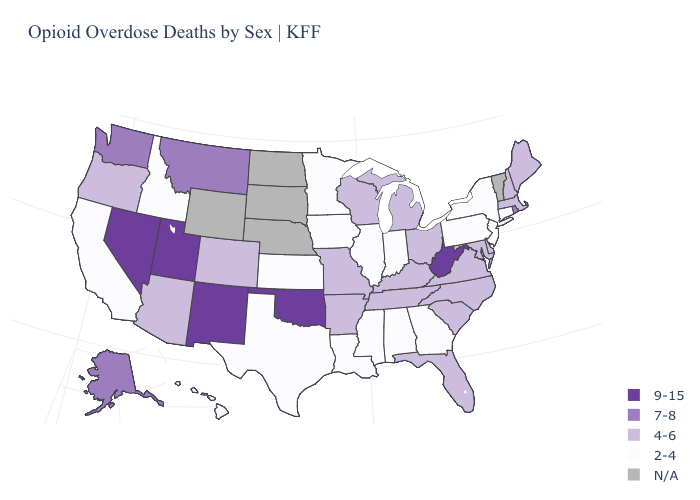Name the states that have a value in the range 4-6?
Quick response, please. Arizona, Arkansas, Colorado, Delaware, Florida, Kentucky, Maine, Maryland, Massachusetts, Michigan, Missouri, New Hampshire, North Carolina, Ohio, Oregon, South Carolina, Tennessee, Virginia, Wisconsin. Does the map have missing data?
Write a very short answer. Yes. Does the map have missing data?
Write a very short answer. Yes. What is the lowest value in the South?
Write a very short answer. 2-4. What is the highest value in the USA?
Be succinct. 9-15. What is the lowest value in the MidWest?
Quick response, please. 2-4. Which states have the lowest value in the MidWest?
Give a very brief answer. Illinois, Indiana, Iowa, Kansas, Minnesota. Name the states that have a value in the range 2-4?
Quick response, please. Alabama, California, Connecticut, Georgia, Hawaii, Idaho, Illinois, Indiana, Iowa, Kansas, Louisiana, Minnesota, Mississippi, New Jersey, New York, Pennsylvania, Texas. What is the highest value in the Northeast ?
Short answer required. 7-8. What is the value of South Carolina?
Quick response, please. 4-6. Is the legend a continuous bar?
Be succinct. No. What is the value of Illinois?
Be succinct. 2-4. Which states have the highest value in the USA?
Write a very short answer. Nevada, New Mexico, Oklahoma, Utah, West Virginia. Name the states that have a value in the range 9-15?
Be succinct. Nevada, New Mexico, Oklahoma, Utah, West Virginia. Which states have the lowest value in the USA?
Write a very short answer. Alabama, California, Connecticut, Georgia, Hawaii, Idaho, Illinois, Indiana, Iowa, Kansas, Louisiana, Minnesota, Mississippi, New Jersey, New York, Pennsylvania, Texas. 